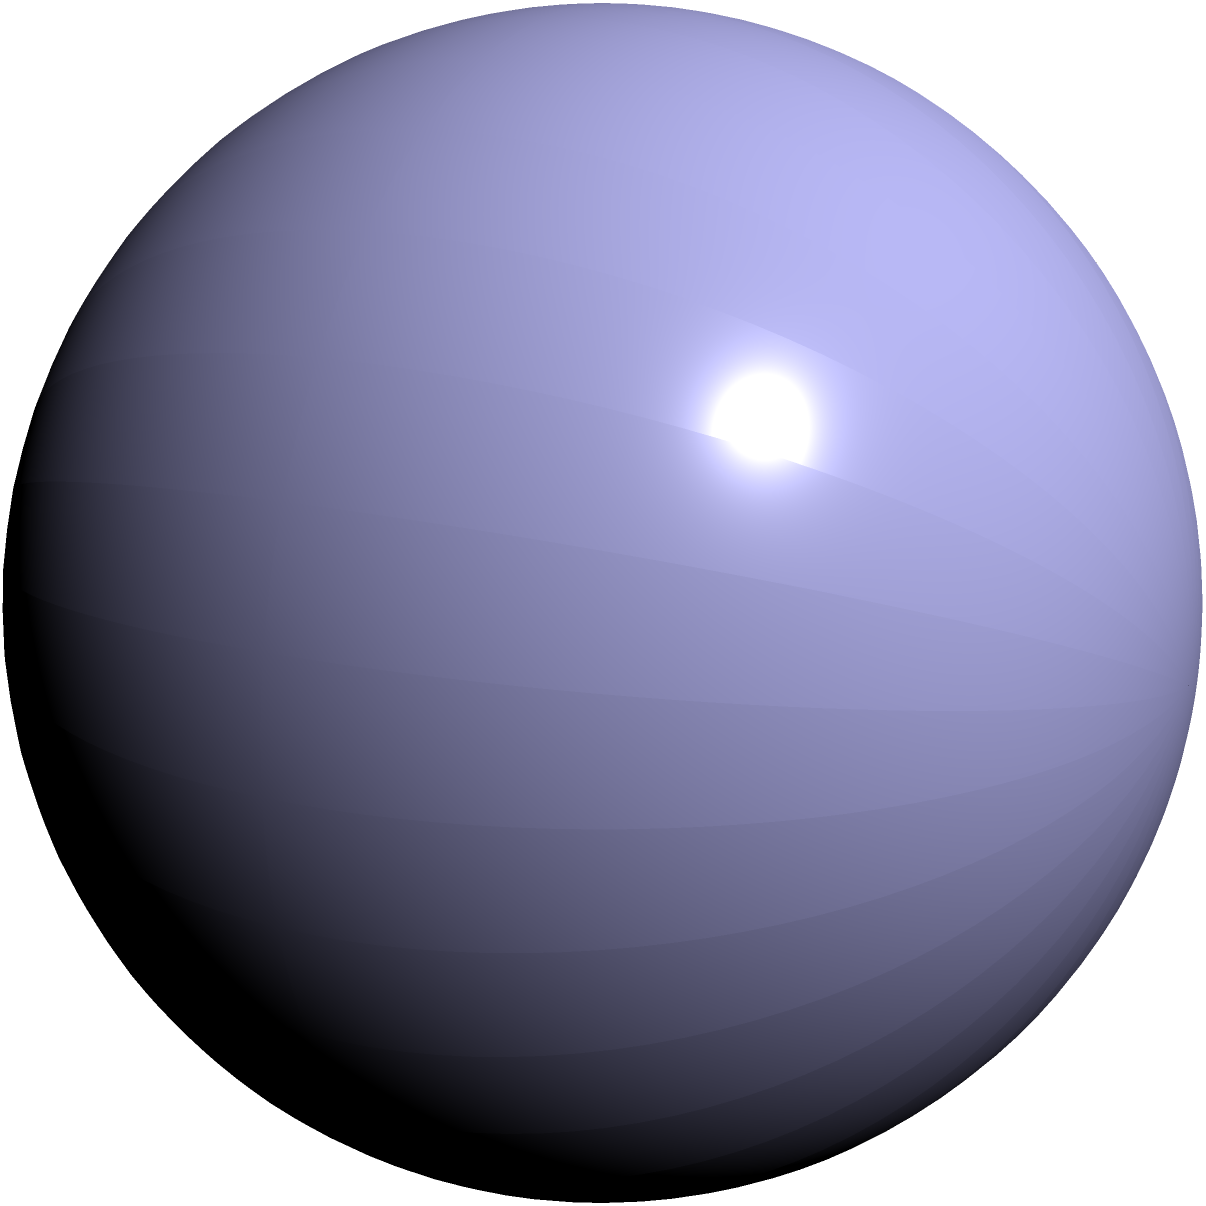In the image above, three surfaces are shown: a torus (blue), a sphere (red), and a Klein bottle (green). Which of these surfaces are homeomorphic to each other? Justify your answer using topological properties. To determine which surfaces are homeomorphic, we need to consider their topological properties:

1. Torus:
   - Has genus 1 (one hole)
   - Is orientable
   - Has Euler characteristic $\chi = 0$

2. Sphere:
   - Has genus 0 (no holes)
   - Is orientable
   - Has Euler characteristic $\chi = 2$

3. Klein bottle:
   - Has no well-defined genus in 3D space (self-intersecting)
   - Is non-orientable
   - Has Euler characteristic $\chi = 0$

Homeomorphism preserves topological properties. Therefore:

- The torus and sphere are not homeomorphic because they have different genera and Euler characteristics.
- The sphere and Klein bottle are not homeomorphic due to different orientability and Euler characteristics.
- The torus and Klein bottle, despite having the same Euler characteristic, are not homeomorphic because one is orientable and the other is non-orientable.

Thus, none of these surfaces are homeomorphic to each other.
Answer: None are homeomorphic 